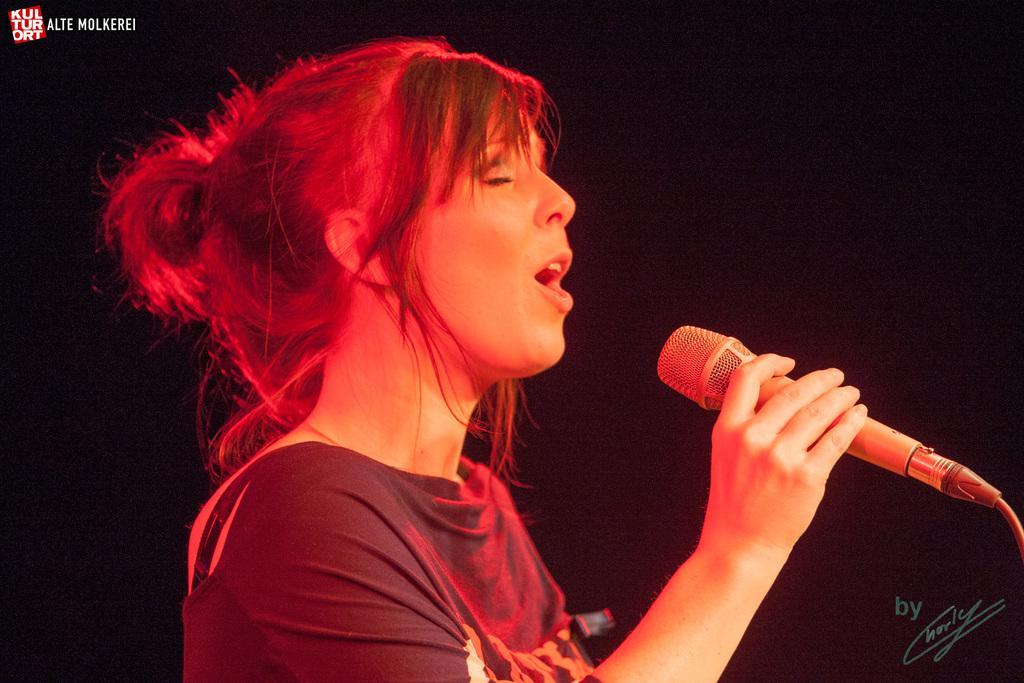How would you summarize this image in a sentence or two? In the middle of the image a woman is standing and holding a microphone and singing. 